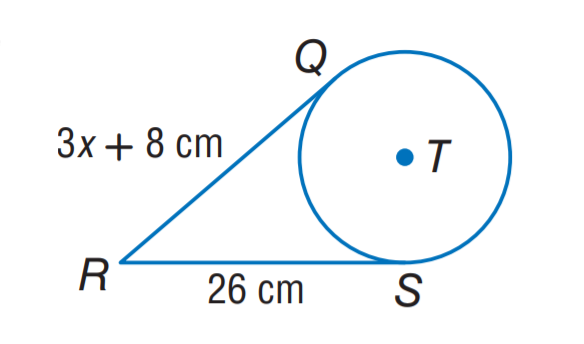Question: The segment is tangent to the circle. Find the value of x.
Choices:
A. 6
B. 8
C. 12
D. 26
Answer with the letter. Answer: A 